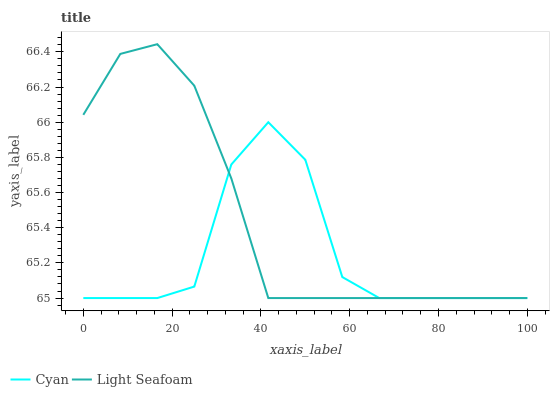Does Cyan have the minimum area under the curve?
Answer yes or no. Yes. Does Light Seafoam have the maximum area under the curve?
Answer yes or no. Yes. Does Light Seafoam have the minimum area under the curve?
Answer yes or no. No. Is Light Seafoam the smoothest?
Answer yes or no. Yes. Is Cyan the roughest?
Answer yes or no. Yes. Is Light Seafoam the roughest?
Answer yes or no. No. Does Cyan have the lowest value?
Answer yes or no. Yes. Does Light Seafoam have the highest value?
Answer yes or no. Yes. Does Light Seafoam intersect Cyan?
Answer yes or no. Yes. Is Light Seafoam less than Cyan?
Answer yes or no. No. Is Light Seafoam greater than Cyan?
Answer yes or no. No. 